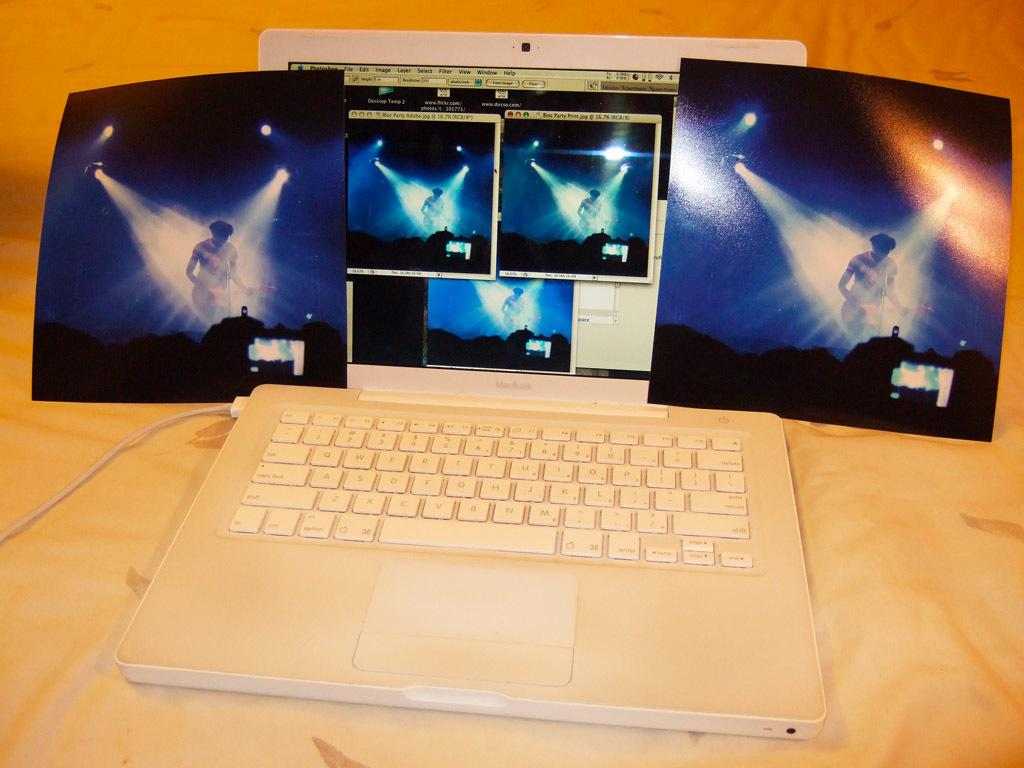<image>
Describe the image concisely. Two photos of a performer next to a Macbook screen that shows the same thing. 